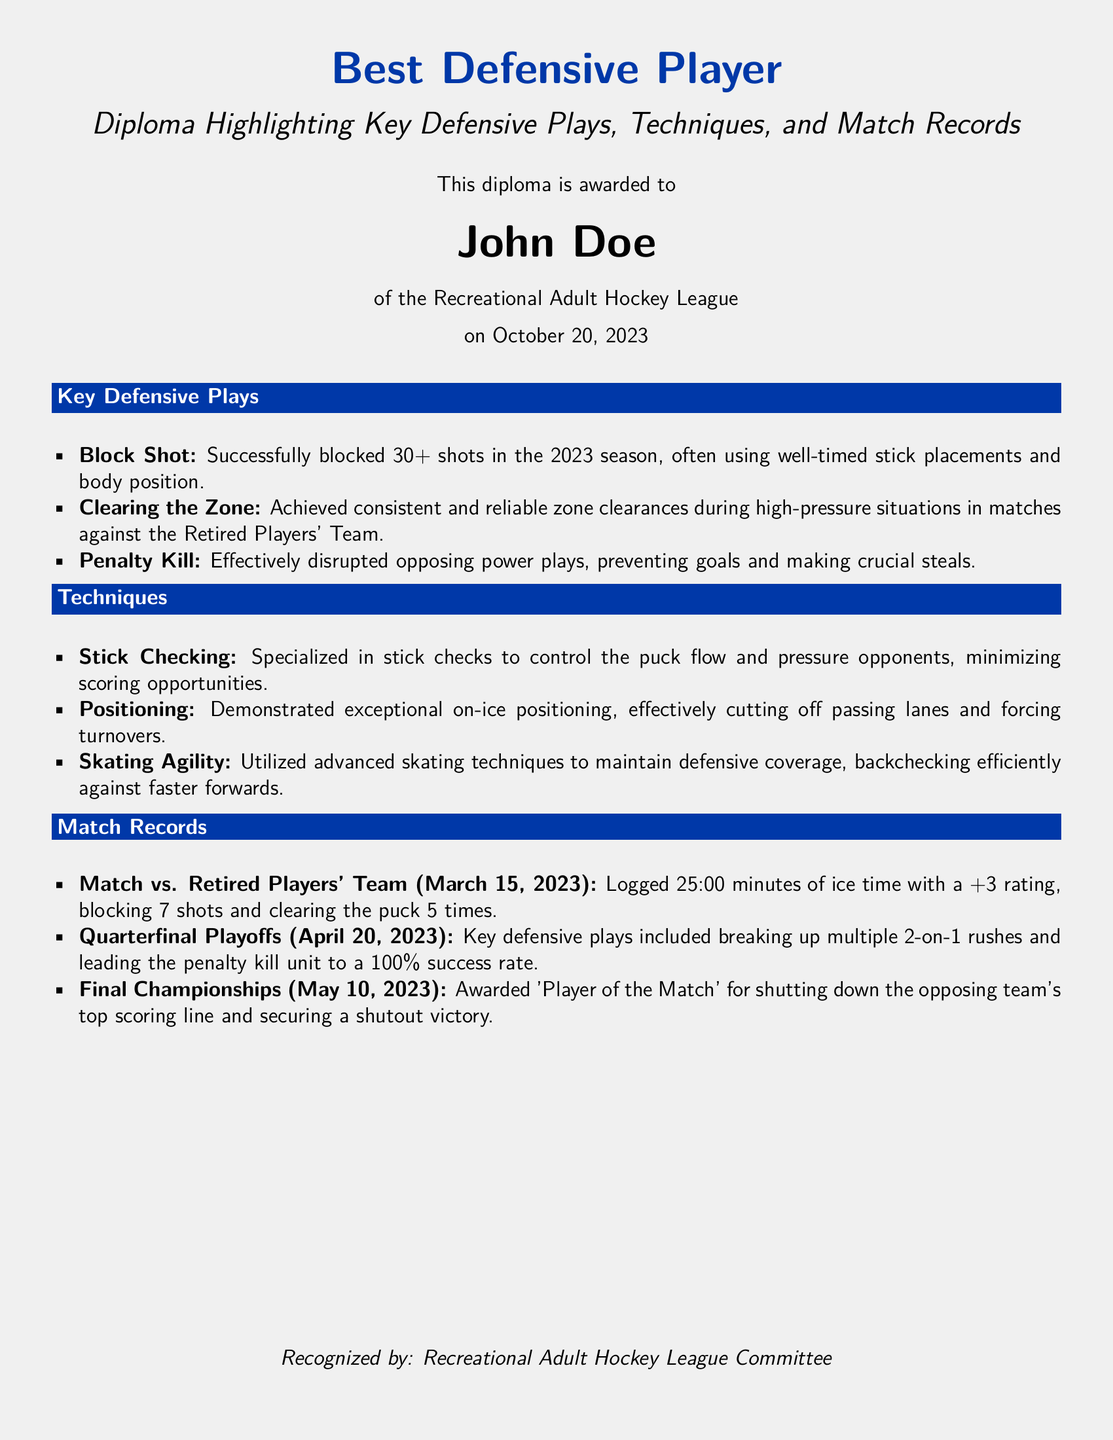What is the name of the award recipient? The document clearly states the name of the award recipient, who is John Doe.
Answer: John Doe When was the diploma awarded? The diploma includes the date on which it was awarded, which is October 20, 2023.
Answer: October 20, 2023 How many shots did John Doe successfully block in the 2023 season? The document mentions that he successfully blocked 30+ shots during that season.
Answer: 30+ What was John Doe's plus-minus rating in the match against the Retired Players' Team? It indicates that he logged a +3 rating in that specific match.
Answer: +3 Which event did John Doe receive 'Player of the Match' for? The document specifies that he received this acknowledgment for the Final Championships on May 10, 2023.
Answer: Final Championships What defensive technique did John Doe specialize in to minimize scoring opportunities? The document lists stick checking as one of the techniques he specialized in.
Answer: Stick Checking What was the outcome of the penalty kill unit during the Quarterfinal Playoffs? It states that the unit achieved a 100% success rate during the playoffs.
Answer: 100% success rate How many minutes of ice time did John Doe log in the match on March 15, 2023? The document states that he logged 25:00 minutes of ice time in that match.
Answer: 25:00 minutes 